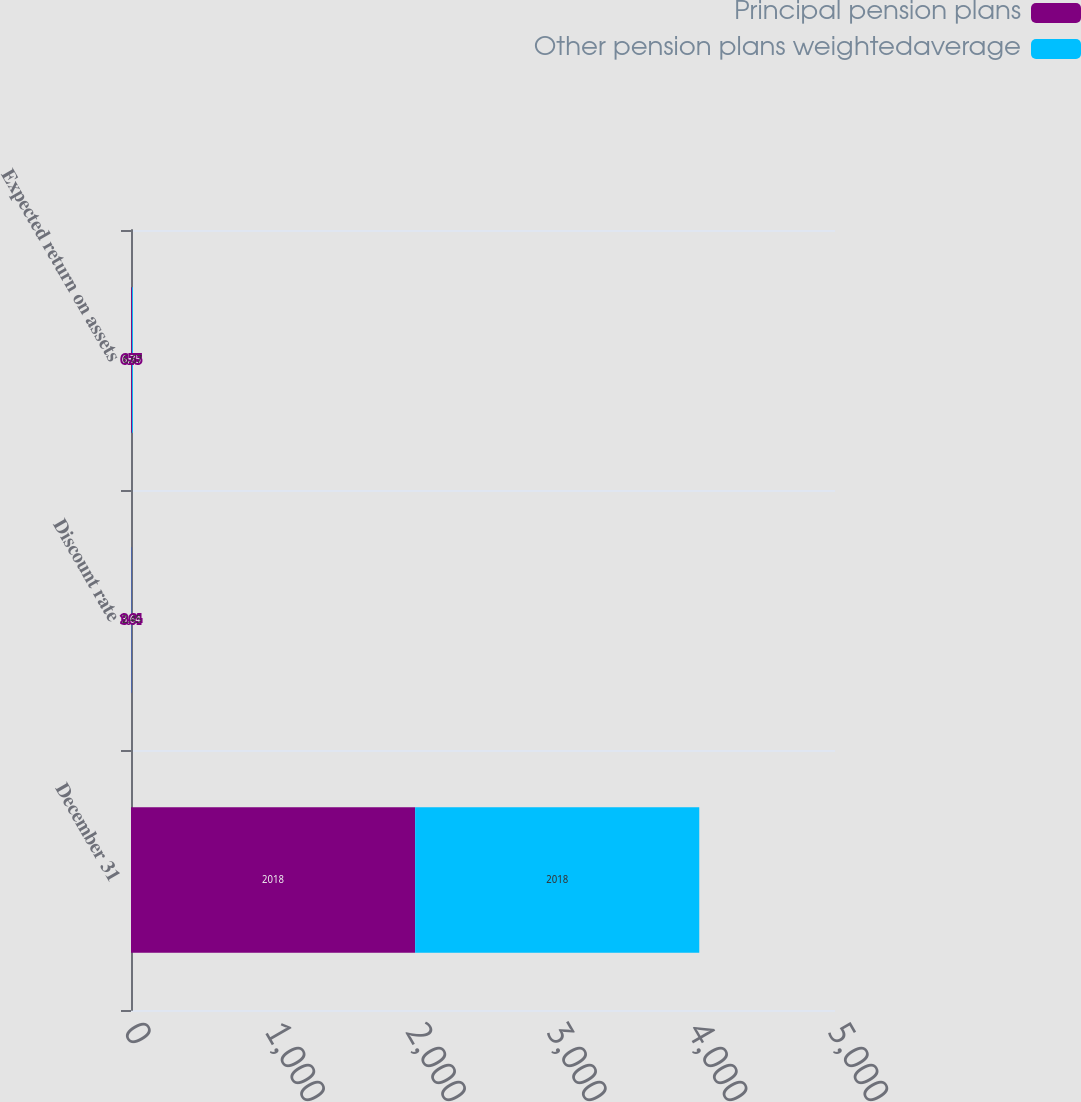<chart> <loc_0><loc_0><loc_500><loc_500><stacked_bar_chart><ecel><fcel>December 31<fcel>Discount rate<fcel>Expected return on assets<nl><fcel>Principal pension plans<fcel>2018<fcel>3.64<fcel>6.75<nl><fcel>Other pension plans weightedaverage<fcel>2018<fcel>2.45<fcel>6.67<nl></chart> 